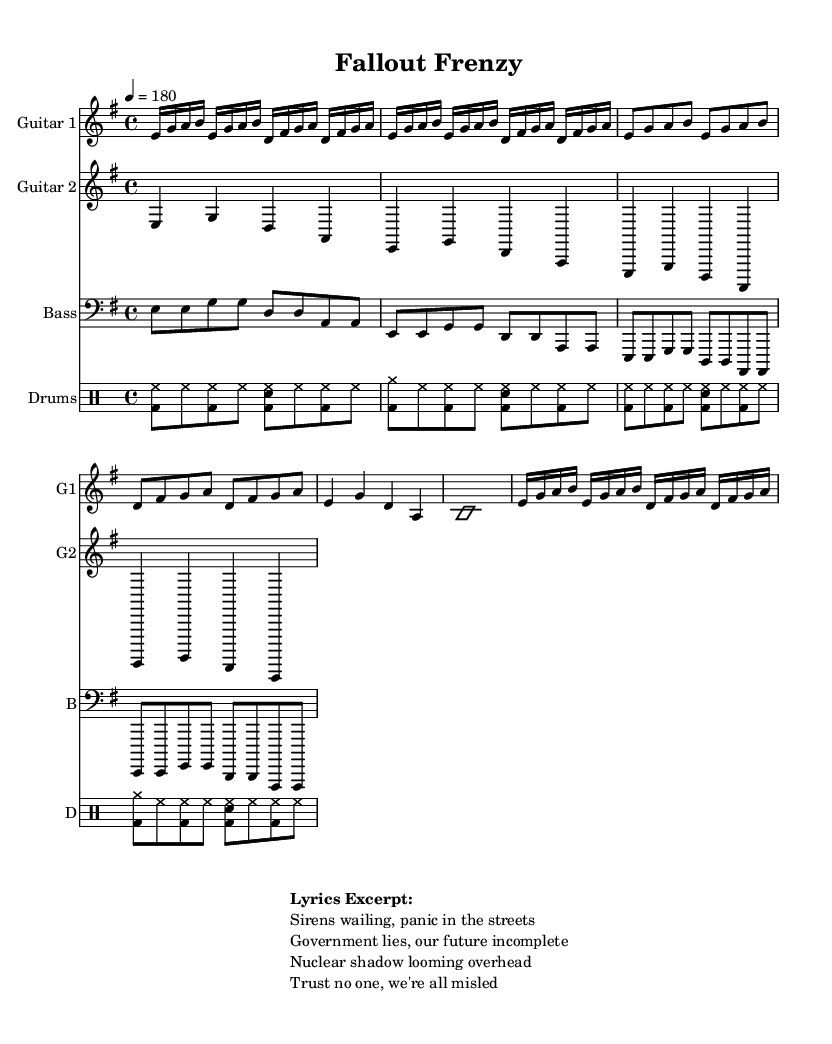What is the key signature of this music? The key signature at the beginning of the music indicates that it is in E minor. This is determined by looking at the sharp or flat symbols placed on the staff. E minor is characterized by one sharp, which corresponds to F#.
Answer: E minor What is the time signature of this music? The time signature displayed in the music is 4/4. This is evident from the notation at the beginning, which indicates that there are four beats per measure and the quarter note gets one beat.
Answer: 4/4 What is the tempo of this piece? The tempo marking in the music states that the piece should be played at 180 beats per minute. This is indicated by the "4 = 180" notation which signifies the number of beats in a minute.
Answer: 180 How many measures are in the chorus section? The chorus section is made up of 4 measures, as indicated by the grouping of notes in that section of the score. Each measure is separated by a vertical bar line that denotes the end of a measure.
Answer: 4 What instruments are included in this score? The score includes four instruments: Guitar 1, Guitar 2, Bass, and Drums. These are identified by the labels provided at the beginning of each staff in the score.
Answer: Guitar 1, Guitar 2, Bass, Drums Which part is labeled as the "Bridge/Solo hint"? The section labeled as "Bridge/Solo hint" is marked by the indication "\improvisationOn" followed by a single sustained note (b1), which is a cue for improvisation in that particular part.
Answer: Bridge/Solo hint What thematic element is present in the lyrics excerpt? The lyrics excerpt reflects a theme of nuclear paranoia and government distrust, as indicated by the phrases discussing "sirens", "government lies", and "nuclear shadow", which evoke a sense of fear and skepticism.
Answer: Nuclear paranoia and government distrust 